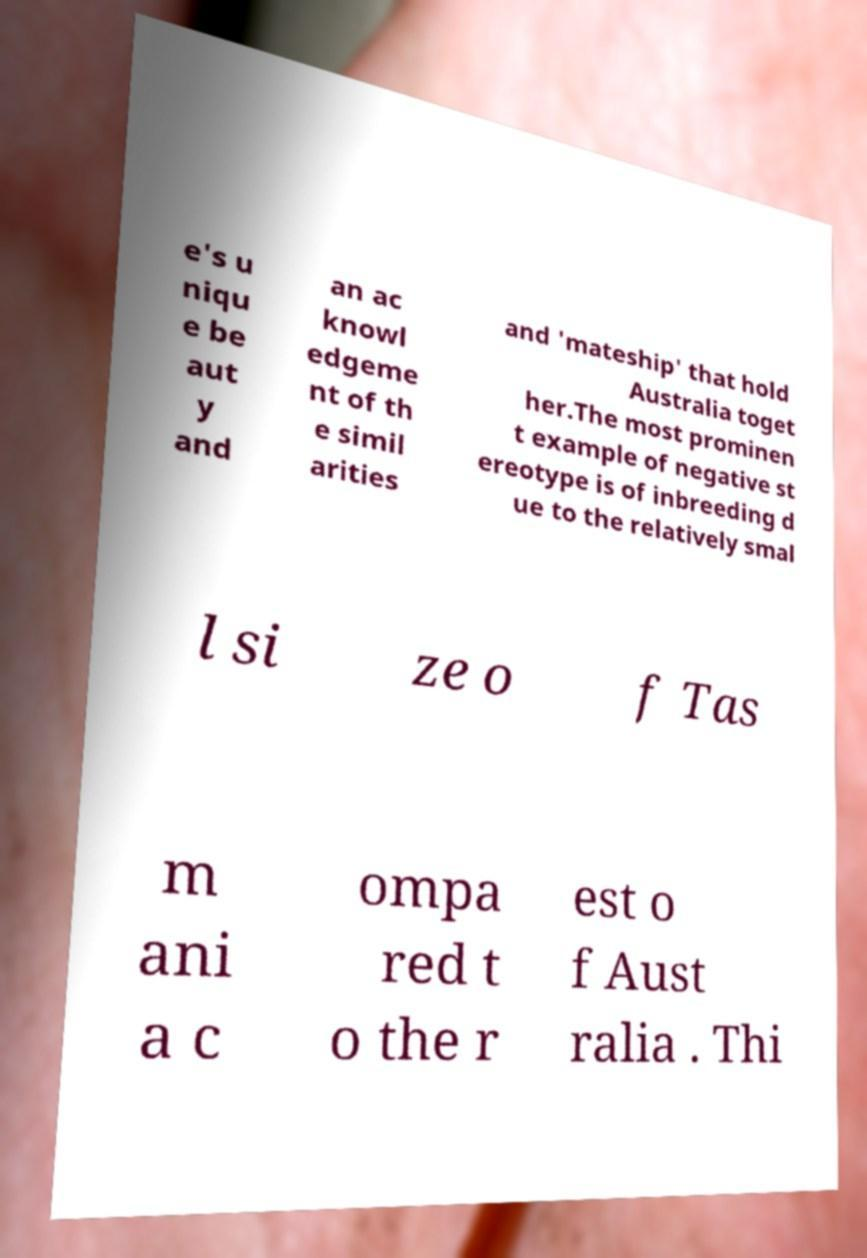Can you accurately transcribe the text from the provided image for me? e's u niqu e be aut y and an ac knowl edgeme nt of th e simil arities and 'mateship' that hold Australia toget her.The most prominen t example of negative st ereotype is of inbreeding d ue to the relatively smal l si ze o f Tas m ani a c ompa red t o the r est o f Aust ralia . Thi 